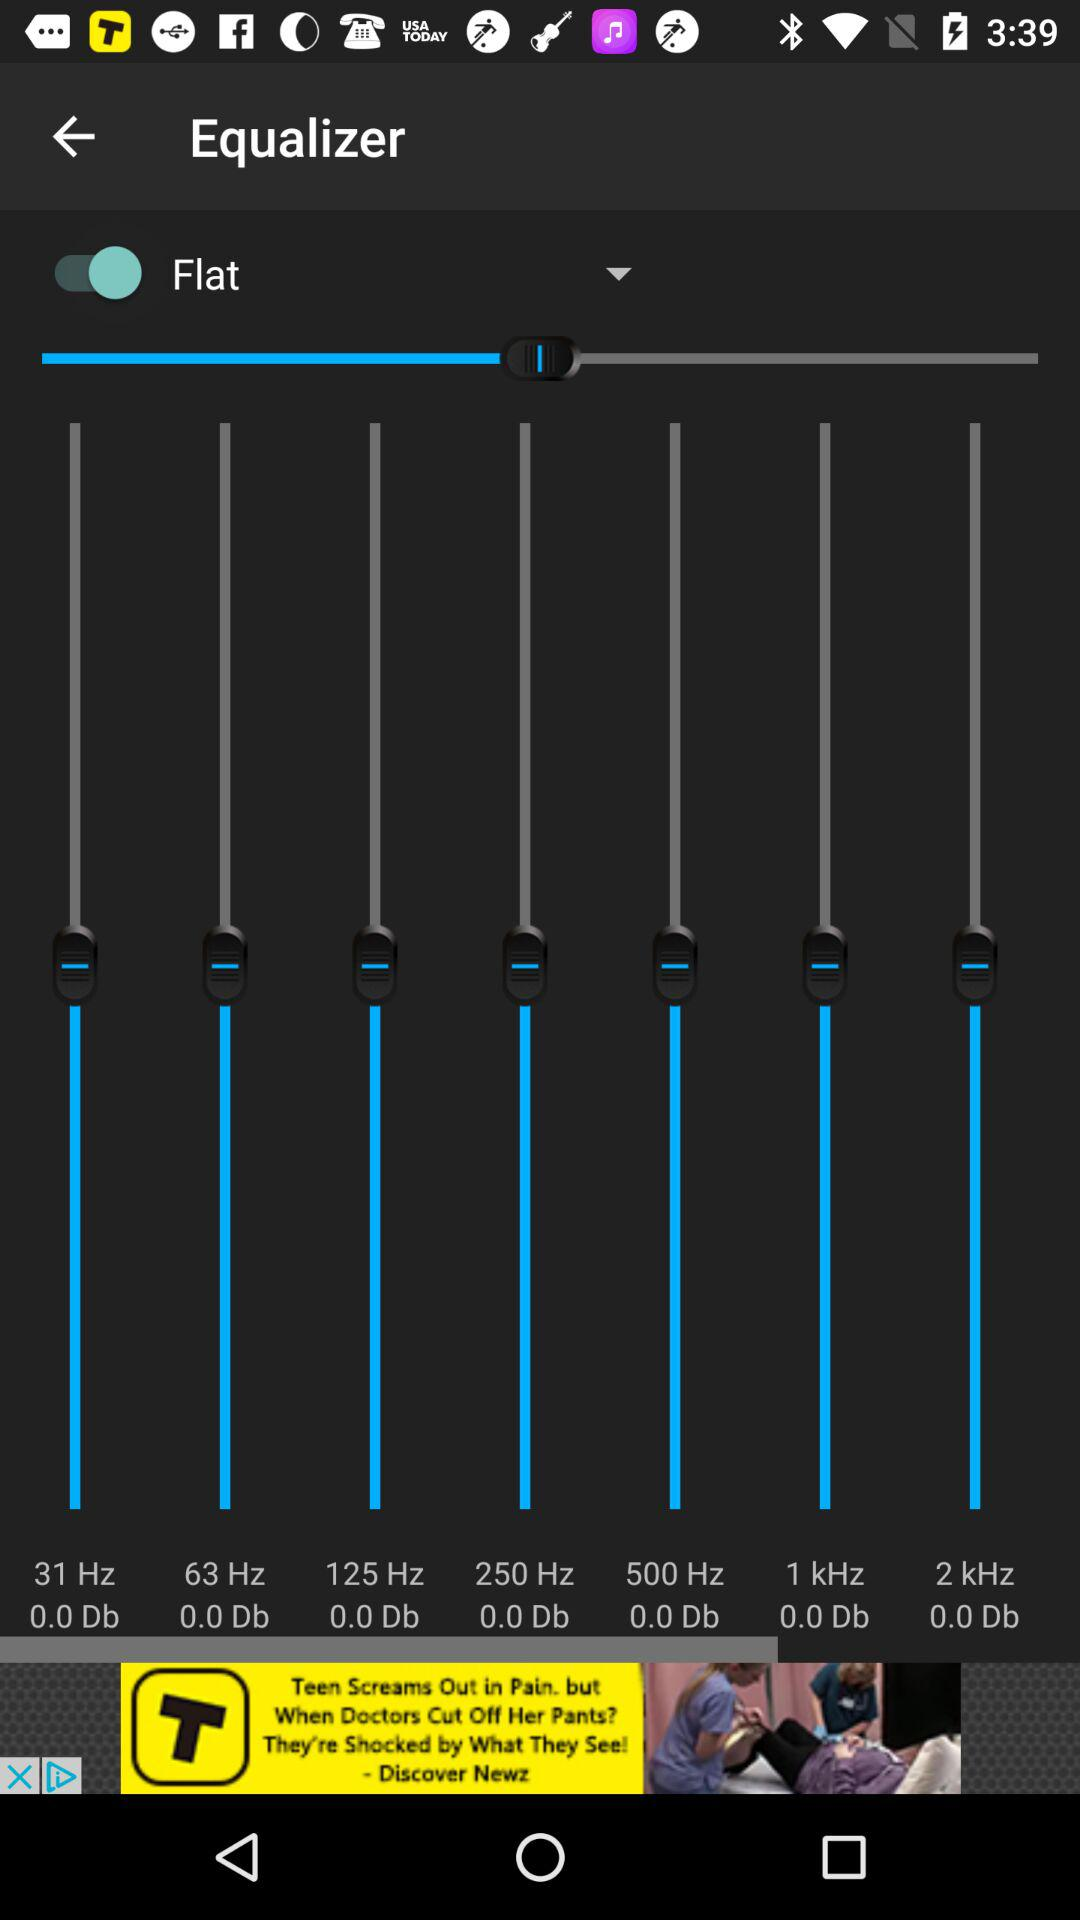What is the status of "Flat"? The status is "on". 